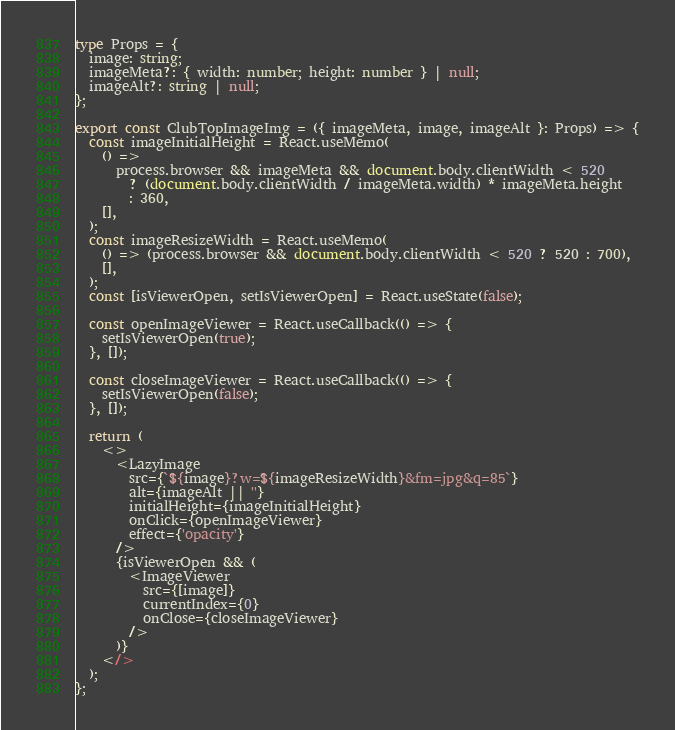<code> <loc_0><loc_0><loc_500><loc_500><_TypeScript_>
type Props = {
  image: string;
  imageMeta?: { width: number; height: number } | null;
  imageAlt?: string | null;
};

export const ClubTopImageImg = ({ imageMeta, image, imageAlt }: Props) => {
  const imageInitialHeight = React.useMemo(
    () =>
      process.browser && imageMeta && document.body.clientWidth < 520
        ? (document.body.clientWidth / imageMeta.width) * imageMeta.height
        : 360,
    [],
  );
  const imageResizeWidth = React.useMemo(
    () => (process.browser && document.body.clientWidth < 520 ? 520 : 700),
    [],
  );
  const [isViewerOpen, setIsViewerOpen] = React.useState(false);

  const openImageViewer = React.useCallback(() => {
    setIsViewerOpen(true);
  }, []);

  const closeImageViewer = React.useCallback(() => {
    setIsViewerOpen(false);
  }, []);

  return (
    <>
      <LazyImage
        src={`${image}?w=${imageResizeWidth}&fm=jpg&q=85`}
        alt={imageAlt || ''}
        initialHeight={imageInitialHeight}
        onClick={openImageViewer}
        effect={'opacity'}
      />
      {isViewerOpen && (
        <ImageViewer
          src={[image]}
          currentIndex={0}
          onClose={closeImageViewer}
        />
      )}
    </>
  );
};
</code> 